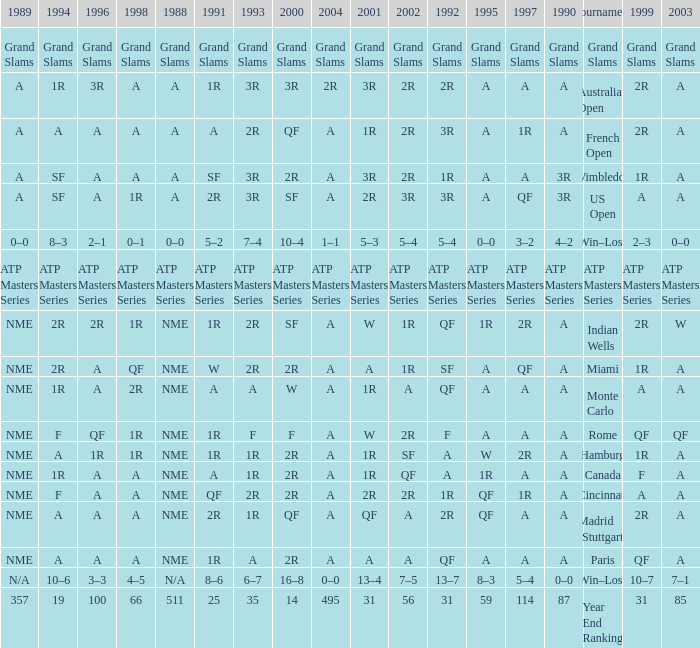What shows for 1988 when 1994 shows 10–6? N/A. 